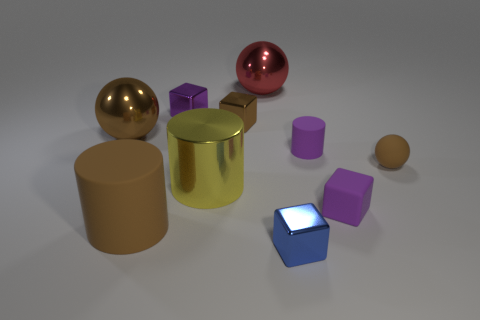Subtract all brown balls. How many were subtracted if there are1brown balls left? 1 Subtract all blocks. How many objects are left? 6 Add 2 shiny balls. How many shiny balls are left? 4 Add 9 large brown cylinders. How many large brown cylinders exist? 10 Subtract 0 red cylinders. How many objects are left? 10 Subtract all brown balls. Subtract all metal spheres. How many objects are left? 6 